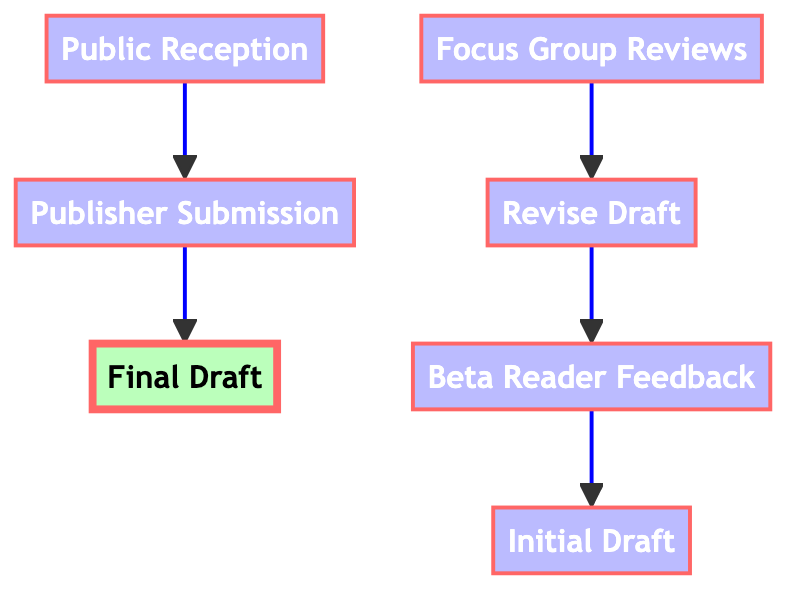What is the starting point of the flow chart? The flow chart starts with the "Initial Draft," which serves as the foundation for the feedback and revision process.
Answer: Initial Draft How many steps are there from Beta Reader Feedback to Revise Draft? There is one direct step from "Beta Reader Feedback" to "Revise Draft" in the diagram, showing a clear flow of the process.
Answer: 1 What is the next step after Focus Group Reviews? The next step after "Focus Group Reviews" is either "Adjust Plot Points" or "Fine-Tune Character Arcs," but since the question asks for the direct next step, it stays within the context of focus groups leading to those adjustments.
Answer: Adjust Plot Points Which node represents the final stage before public reception? The final stage before "Public Reception" is "Publisher Submission," indicating the last step of submitting the final draft to publishers.
Answer: Publisher Submission How many nodes are included in the diagram? The diagram includes a total of seven nodes, representing distinct stages in the feedback and publishing process.
Answer: 7 What is the relationship between Initial Draft and Beta Reader Feedback? The relationship indicates that the "Initial Draft" leads directly to "Beta Reader Feedback," making it a crucial immediate step in the feedback process.
Answer: Directly leads to What are the two paths available immediately after the Final Draft? After the "Final Draft," the next steps are "Publisher Submission" and "Marketing Strategy," both of which are crucial for moving forward with the novel.
Answer: Publisher Submission, Marketing Strategy Which step follows Revise Draft? After "Revise Draft," the flow leads to "Focus Group Reviews," indicating that this phase follows revisions based on feedback.
Answer: Focus Group Reviews What is the role of Public Reception in the process? The role of "Public Reception" is to gather reader and critic responses after the book's release, which can influence future projects for the author.
Answer: Influence future projects 